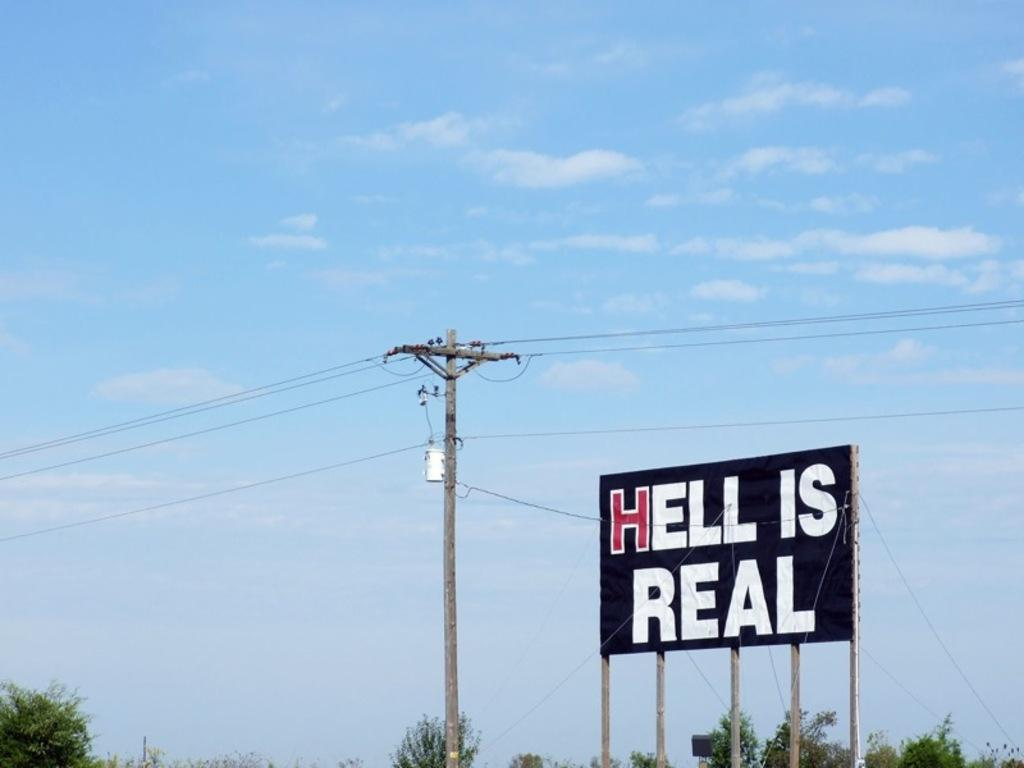<image>
Create a compact narrative representing the image presented. A signboard that says "Hell is Real" is surrounded by blue sky. 